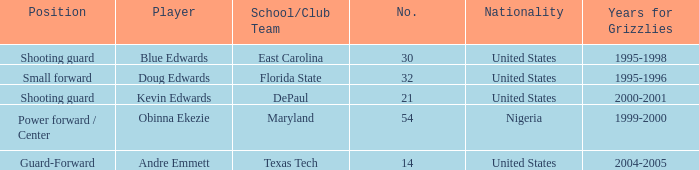When did no. 32 play for grizzles 1995-1996. 